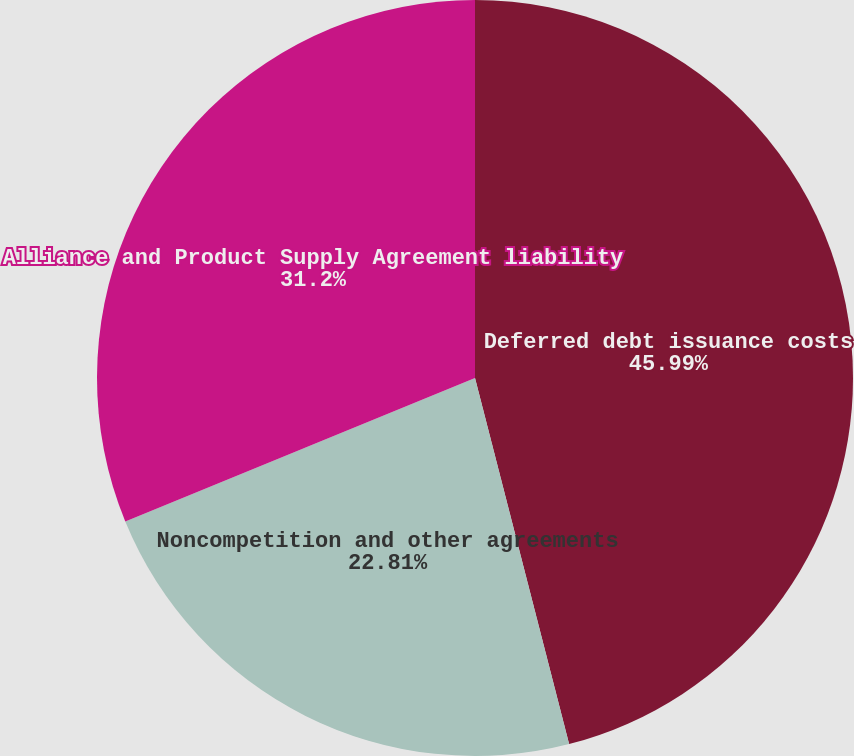Convert chart. <chart><loc_0><loc_0><loc_500><loc_500><pie_chart><fcel>Deferred debt issuance costs<fcel>Noncompetition and other agreements<fcel>Alliance and Product Supply Agreement liability<nl><fcel>46.0%<fcel>22.81%<fcel>31.2%<nl></chart> 